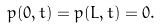<formula> <loc_0><loc_0><loc_500><loc_500>p ( 0 , t ) = p ( L , t ) = 0 .</formula> 